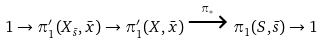Convert formula to latex. <formula><loc_0><loc_0><loc_500><loc_500>1 \to \pi _ { 1 } ^ { \prime } ( X _ { \bar { s } } , \bar { x } ) \to \pi _ { 1 } ^ { \prime } ( X , \bar { x } ) \xrightarrow { \pi _ { * } } \pi _ { 1 } ( S , \bar { s } ) \to 1</formula> 